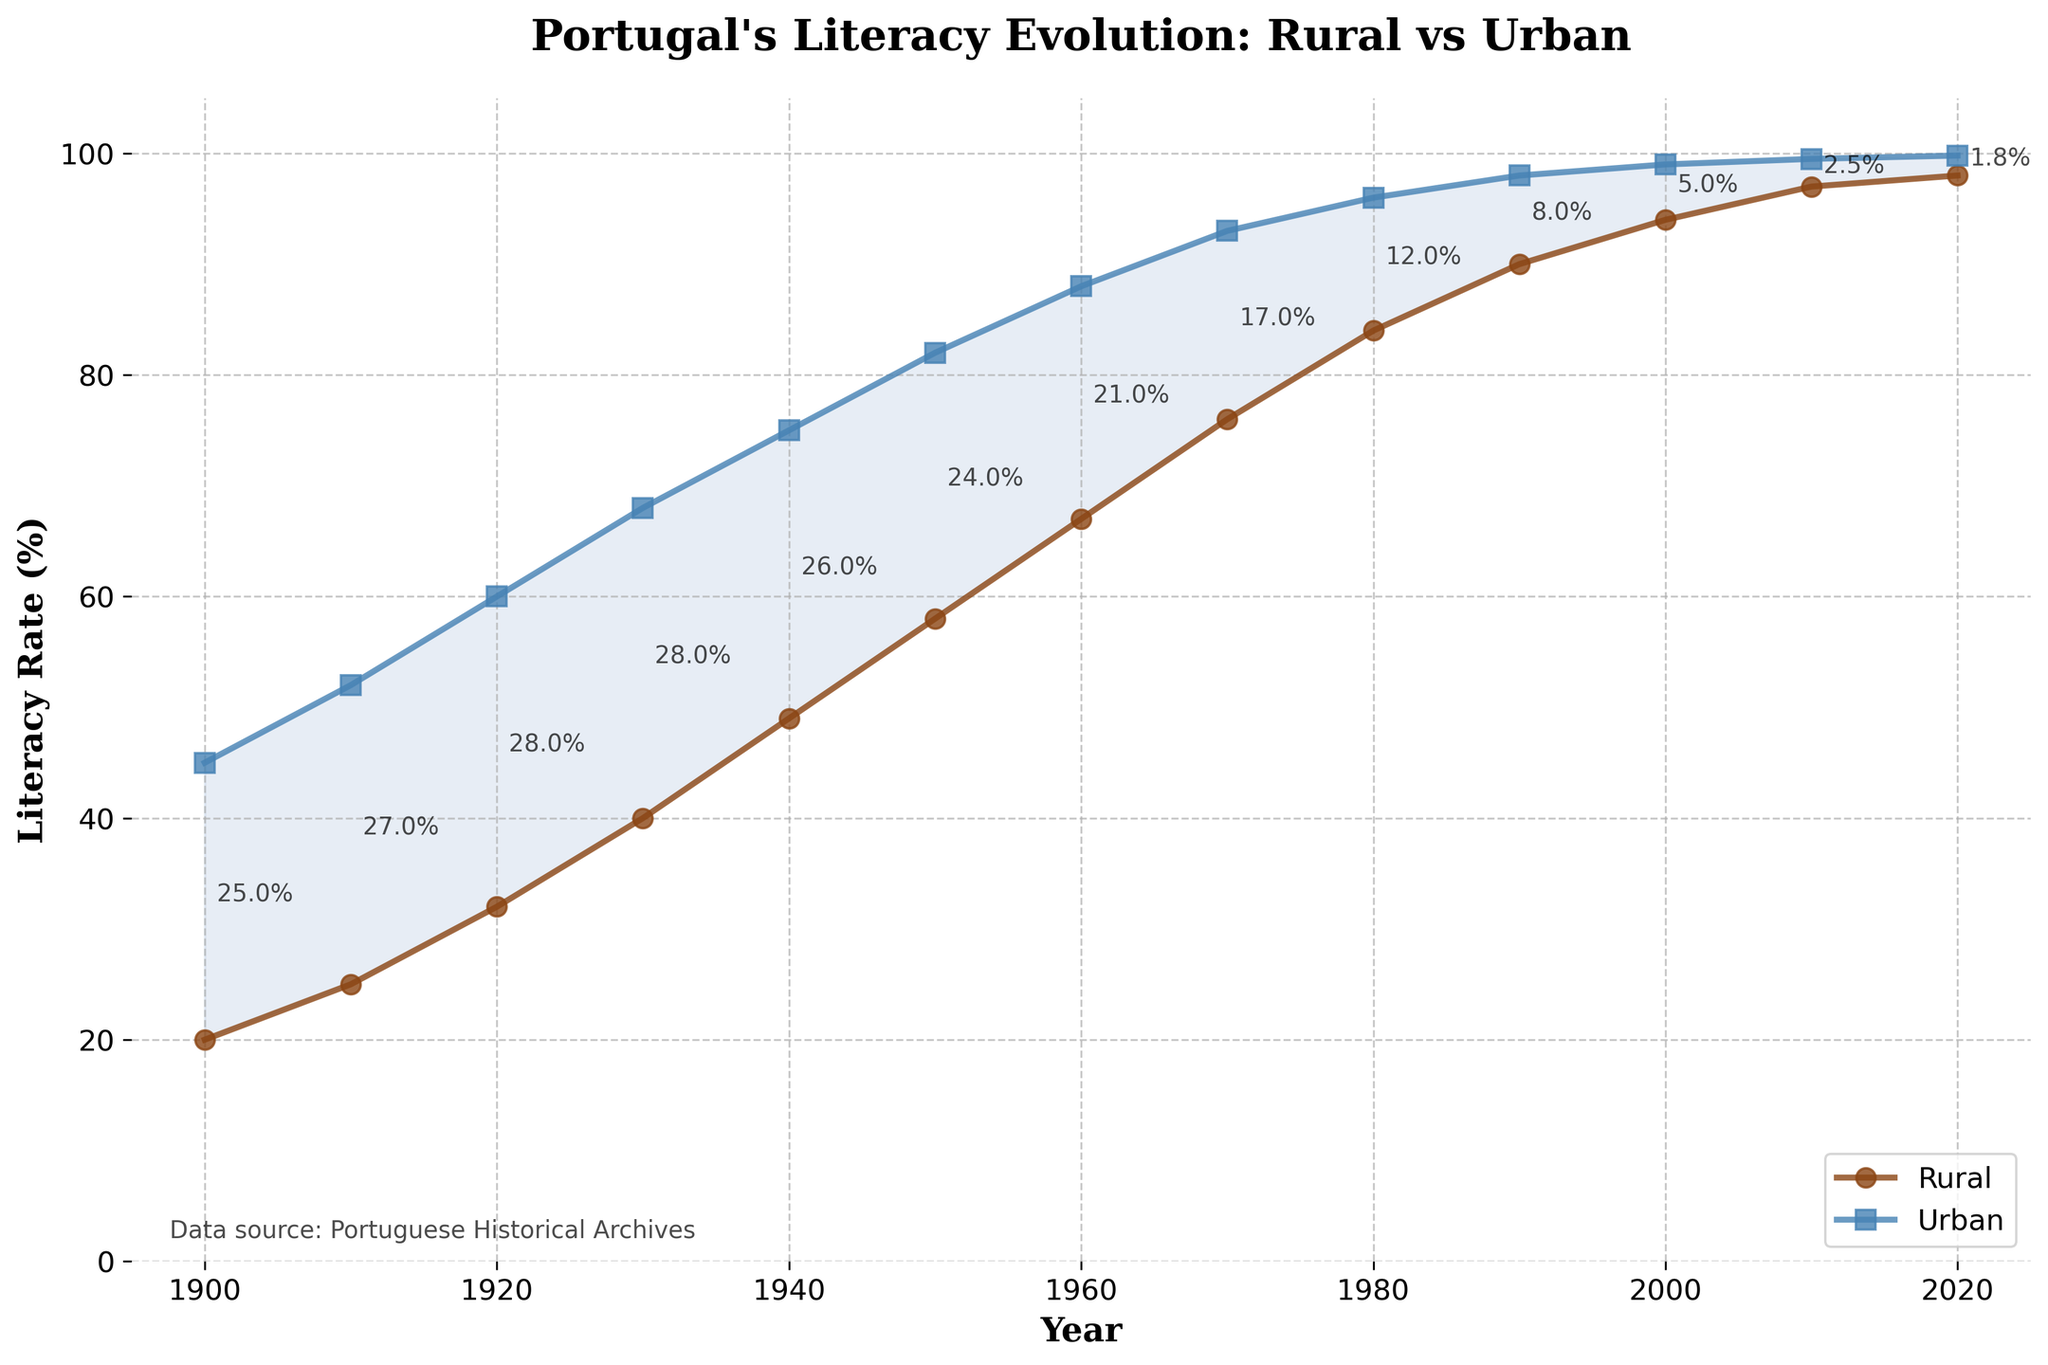What's the difference in literacy rates between rural and urban areas in 1900? Identify the literacy rates for rural (20%) and urban (45%) areas in 1900. Calculate the difference by subtracting rural from urban: 45% - 20% = 25%.
Answer: 25% How much did the rural literacy rate increase from 1900 to 1960? Identify the rural literacy rates in 1900 (20%) and 1960 (67%). Calculate the increase by subtracting the 1900 rate from the 1960 rate: 67% - 20% = 47%.
Answer: 47% By how much did the urban literacy rate surpass the rural literacy rate in 1930? Identify the literacy rates for rural (40%) and urban (68%) areas in 1930. Calculate the surplus by subtracting rural from urban: 68% - 40% = 28%.
Answer: 28% Did the urban or rural literacy rate grow faster between 1950 and 1970? Calculate the growth for both areas between 1950 and 1970. Rural growth: 76% - 58% = 18%. Urban growth: 93% - 82% = 11%. Compare the two: 18% > 11%, thus rural grew faster.
Answer: Rural What year did the literacy rates in both rural and urban areas exceed 90%? Examine the years where literacy rates in both areas exceeded 90%. In 1990, rural has 90% and urban has 98%, both exceeding 90% for the first time.
Answer: 1990 What is the average literacy rate for rural areas in 2000 and 2020? Identify the rural literacy rates in 2000 (94%) and 2020 (98%). Calculate the average: (94% + 98%) / 2 = 96%.
Answer: 96% How did the gap between rural and urban literacy rates change from 1910 to 2020? Calculate the gaps for 1910 and 2020. In 1910: 52% - 25% = 27%. In 2020: 99.8% - 98% = 1.8%. The gap reduced from 27% to 1.8%.
Answer: Reduced What is the color used to represent urban literacy rates on the plot? Identify the visual attributes of the plot. The line representing urban literacy rates is blue.
Answer: Blue Which decade shows the highest increase in rural literacy rate? Examine the increases: 1900-1910 (5%), 1910-1920 (7%), 1920-1930 (8%), 1930-1940 (9%), 1940-1950 (9%), 1950-1960 (9%), 1960-1970 (9%), 1970-1980 (8%), 1980-1990 (6%), 1990-2000 (4%), 2000-2010 (3%), 2010-2020 (1%). The decade with the highest increase is 1930-1940, 1940-1950, 1950-1960 and 1960-1970, each with 9%.
Answer: 1930-1970 During which year did the rural literacy rate first reach 50%? Locate the year where the rural literacy rate first reaches or exceeds 50%. In 1940, rural literacy rate reaches 49%, while in 1950, it is 58%. Thus, it first reaches 50% in 1950.
Answer: 1950 